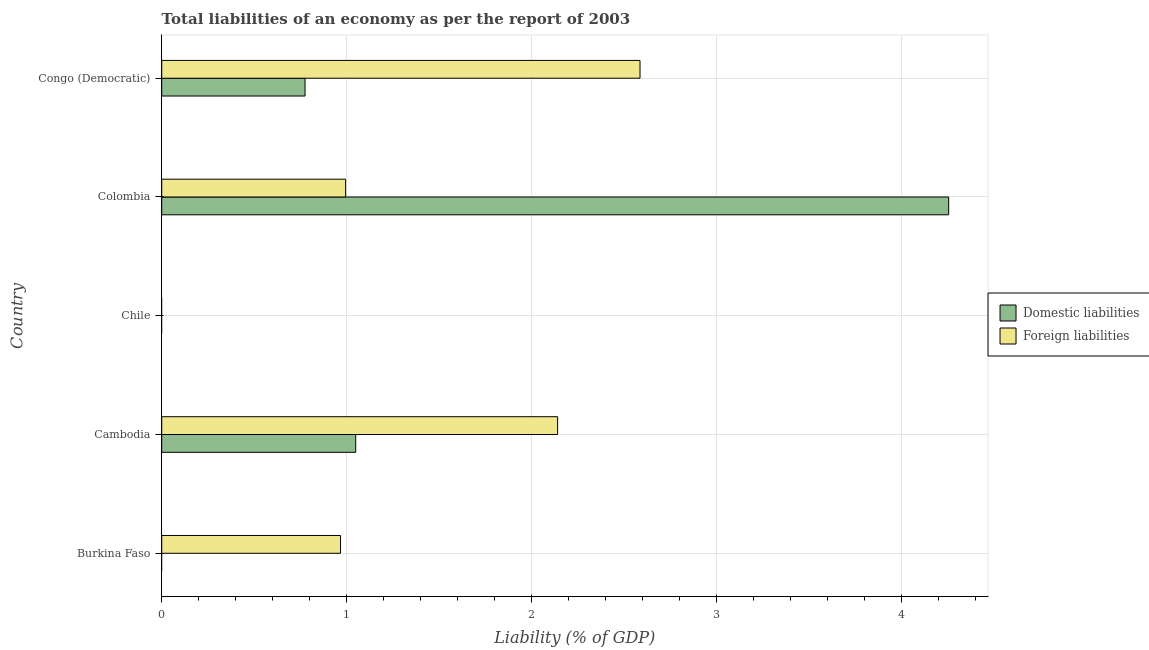Are the number of bars per tick equal to the number of legend labels?
Your response must be concise. No. Are the number of bars on each tick of the Y-axis equal?
Provide a succinct answer. No. How many bars are there on the 5th tick from the top?
Make the answer very short. 1. What is the label of the 1st group of bars from the top?
Offer a very short reply. Congo (Democratic). What is the incurrence of foreign liabilities in Cambodia?
Offer a very short reply. 2.14. Across all countries, what is the maximum incurrence of domestic liabilities?
Keep it short and to the point. 4.26. Across all countries, what is the minimum incurrence of domestic liabilities?
Offer a very short reply. 0. In which country was the incurrence of foreign liabilities maximum?
Provide a succinct answer. Congo (Democratic). What is the total incurrence of domestic liabilities in the graph?
Offer a terse response. 6.08. What is the difference between the incurrence of foreign liabilities in Burkina Faso and that in Congo (Democratic)?
Offer a very short reply. -1.62. What is the difference between the incurrence of domestic liabilities in Cambodia and the incurrence of foreign liabilities in Chile?
Your answer should be very brief. 1.05. What is the average incurrence of foreign liabilities per country?
Keep it short and to the point. 1.34. What is the difference between the incurrence of foreign liabilities and incurrence of domestic liabilities in Colombia?
Make the answer very short. -3.26. In how many countries, is the incurrence of domestic liabilities greater than 0.8 %?
Provide a short and direct response. 2. What is the ratio of the incurrence of foreign liabilities in Cambodia to that in Colombia?
Your response must be concise. 2.15. Is the difference between the incurrence of foreign liabilities in Cambodia and Congo (Democratic) greater than the difference between the incurrence of domestic liabilities in Cambodia and Congo (Democratic)?
Provide a succinct answer. No. What is the difference between the highest and the second highest incurrence of domestic liabilities?
Make the answer very short. 3.21. What is the difference between the highest and the lowest incurrence of foreign liabilities?
Provide a short and direct response. 2.59. How many bars are there?
Offer a very short reply. 7. Are all the bars in the graph horizontal?
Provide a succinct answer. Yes. How many countries are there in the graph?
Provide a succinct answer. 5. What is the difference between two consecutive major ticks on the X-axis?
Give a very brief answer. 1. Are the values on the major ticks of X-axis written in scientific E-notation?
Give a very brief answer. No. Where does the legend appear in the graph?
Your answer should be compact. Center right. How many legend labels are there?
Make the answer very short. 2. What is the title of the graph?
Ensure brevity in your answer.  Total liabilities of an economy as per the report of 2003. Does "Manufacturing industries and construction" appear as one of the legend labels in the graph?
Keep it short and to the point. No. What is the label or title of the X-axis?
Your answer should be very brief. Liability (% of GDP). What is the Liability (% of GDP) in Foreign liabilities in Burkina Faso?
Your answer should be very brief. 0.97. What is the Liability (% of GDP) of Domestic liabilities in Cambodia?
Keep it short and to the point. 1.05. What is the Liability (% of GDP) in Foreign liabilities in Cambodia?
Provide a succinct answer. 2.14. What is the Liability (% of GDP) of Domestic liabilities in Chile?
Make the answer very short. 0. What is the Liability (% of GDP) of Foreign liabilities in Chile?
Your answer should be very brief. 0. What is the Liability (% of GDP) of Domestic liabilities in Colombia?
Your answer should be very brief. 4.26. What is the Liability (% of GDP) in Foreign liabilities in Colombia?
Provide a short and direct response. 0.99. What is the Liability (% of GDP) of Domestic liabilities in Congo (Democratic)?
Make the answer very short. 0.78. What is the Liability (% of GDP) in Foreign liabilities in Congo (Democratic)?
Your answer should be compact. 2.59. Across all countries, what is the maximum Liability (% of GDP) of Domestic liabilities?
Provide a succinct answer. 4.26. Across all countries, what is the maximum Liability (% of GDP) of Foreign liabilities?
Offer a very short reply. 2.59. Across all countries, what is the minimum Liability (% of GDP) of Domestic liabilities?
Keep it short and to the point. 0. Across all countries, what is the minimum Liability (% of GDP) of Foreign liabilities?
Provide a short and direct response. 0. What is the total Liability (% of GDP) of Domestic liabilities in the graph?
Make the answer very short. 6.08. What is the total Liability (% of GDP) of Foreign liabilities in the graph?
Make the answer very short. 6.69. What is the difference between the Liability (% of GDP) in Foreign liabilities in Burkina Faso and that in Cambodia?
Offer a terse response. -1.17. What is the difference between the Liability (% of GDP) in Foreign liabilities in Burkina Faso and that in Colombia?
Your answer should be compact. -0.03. What is the difference between the Liability (% of GDP) in Foreign liabilities in Burkina Faso and that in Congo (Democratic)?
Offer a very short reply. -1.62. What is the difference between the Liability (% of GDP) in Domestic liabilities in Cambodia and that in Colombia?
Give a very brief answer. -3.21. What is the difference between the Liability (% of GDP) in Foreign liabilities in Cambodia and that in Colombia?
Offer a very short reply. 1.15. What is the difference between the Liability (% of GDP) of Domestic liabilities in Cambodia and that in Congo (Democratic)?
Provide a short and direct response. 0.27. What is the difference between the Liability (% of GDP) in Foreign liabilities in Cambodia and that in Congo (Democratic)?
Your response must be concise. -0.45. What is the difference between the Liability (% of GDP) of Domestic liabilities in Colombia and that in Congo (Democratic)?
Provide a succinct answer. 3.48. What is the difference between the Liability (% of GDP) in Foreign liabilities in Colombia and that in Congo (Democratic)?
Offer a very short reply. -1.59. What is the difference between the Liability (% of GDP) of Domestic liabilities in Cambodia and the Liability (% of GDP) of Foreign liabilities in Colombia?
Ensure brevity in your answer.  0.05. What is the difference between the Liability (% of GDP) of Domestic liabilities in Cambodia and the Liability (% of GDP) of Foreign liabilities in Congo (Democratic)?
Provide a succinct answer. -1.54. What is the difference between the Liability (% of GDP) in Domestic liabilities in Colombia and the Liability (% of GDP) in Foreign liabilities in Congo (Democratic)?
Provide a succinct answer. 1.67. What is the average Liability (% of GDP) of Domestic liabilities per country?
Your response must be concise. 1.22. What is the average Liability (% of GDP) in Foreign liabilities per country?
Give a very brief answer. 1.34. What is the difference between the Liability (% of GDP) of Domestic liabilities and Liability (% of GDP) of Foreign liabilities in Cambodia?
Your answer should be very brief. -1.09. What is the difference between the Liability (% of GDP) in Domestic liabilities and Liability (% of GDP) in Foreign liabilities in Colombia?
Your response must be concise. 3.26. What is the difference between the Liability (% of GDP) in Domestic liabilities and Liability (% of GDP) in Foreign liabilities in Congo (Democratic)?
Your answer should be compact. -1.81. What is the ratio of the Liability (% of GDP) of Foreign liabilities in Burkina Faso to that in Cambodia?
Offer a terse response. 0.45. What is the ratio of the Liability (% of GDP) in Foreign liabilities in Burkina Faso to that in Colombia?
Provide a succinct answer. 0.97. What is the ratio of the Liability (% of GDP) in Foreign liabilities in Burkina Faso to that in Congo (Democratic)?
Your answer should be very brief. 0.37. What is the ratio of the Liability (% of GDP) in Domestic liabilities in Cambodia to that in Colombia?
Your response must be concise. 0.25. What is the ratio of the Liability (% of GDP) in Foreign liabilities in Cambodia to that in Colombia?
Offer a very short reply. 2.15. What is the ratio of the Liability (% of GDP) of Domestic liabilities in Cambodia to that in Congo (Democratic)?
Provide a short and direct response. 1.35. What is the ratio of the Liability (% of GDP) in Foreign liabilities in Cambodia to that in Congo (Democratic)?
Give a very brief answer. 0.83. What is the ratio of the Liability (% of GDP) in Domestic liabilities in Colombia to that in Congo (Democratic)?
Offer a terse response. 5.49. What is the ratio of the Liability (% of GDP) in Foreign liabilities in Colombia to that in Congo (Democratic)?
Provide a succinct answer. 0.38. What is the difference between the highest and the second highest Liability (% of GDP) of Domestic liabilities?
Make the answer very short. 3.21. What is the difference between the highest and the second highest Liability (% of GDP) in Foreign liabilities?
Keep it short and to the point. 0.45. What is the difference between the highest and the lowest Liability (% of GDP) of Domestic liabilities?
Make the answer very short. 4.26. What is the difference between the highest and the lowest Liability (% of GDP) in Foreign liabilities?
Your answer should be very brief. 2.59. 